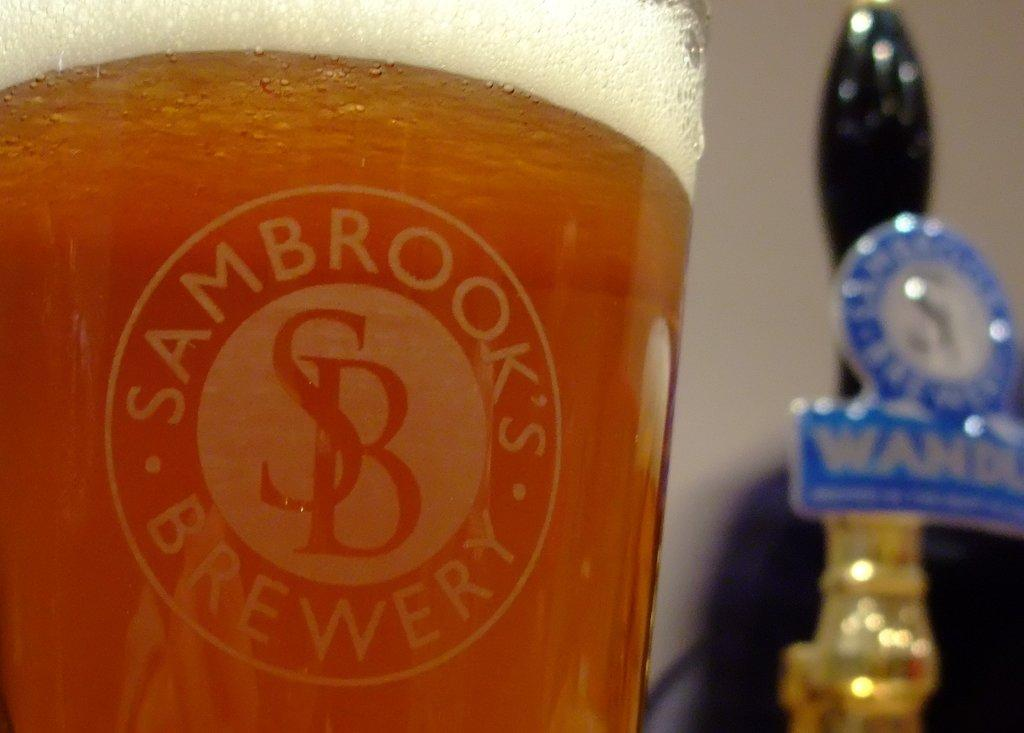Provide a one-sentence caption for the provided image. A glass full of liquid displays the name Sambrook's Brewery. 